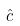Convert formula to latex. <formula><loc_0><loc_0><loc_500><loc_500>\hat { c }</formula> 